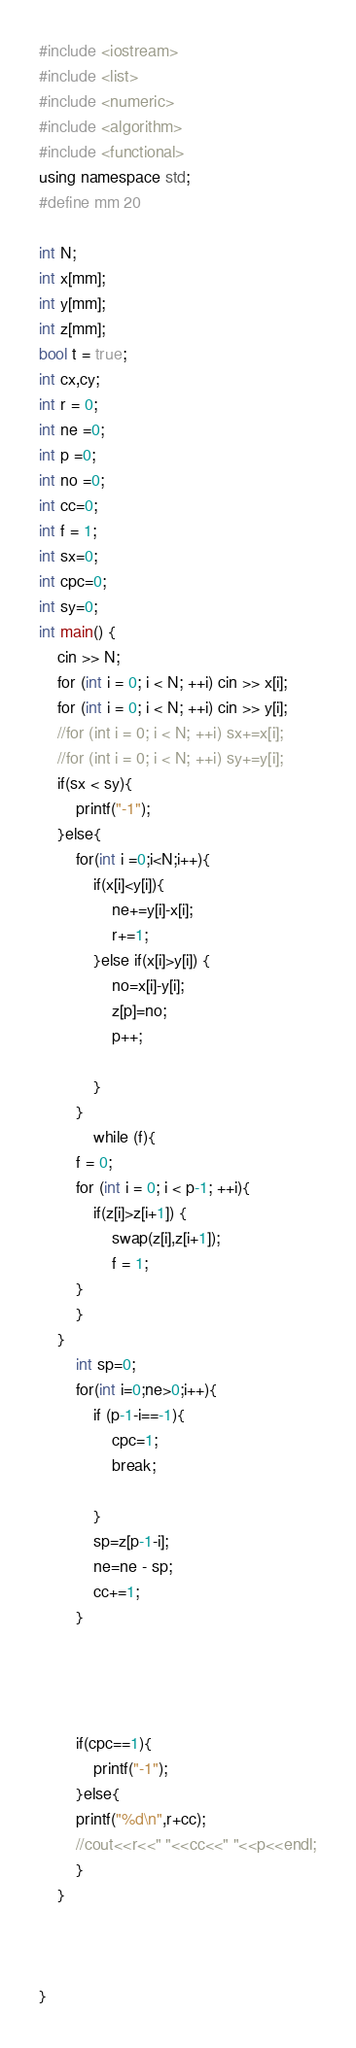<code> <loc_0><loc_0><loc_500><loc_500><_C++_>#include <iostream>
#include <list>
#include <numeric>
#include <algorithm>
#include <functional>
using namespace std;
#define mm 20

int N;
int x[mm];
int y[mm];
int z[mm];
bool t = true;  
int cx,cy;
int r = 0;
int ne =0;
int p =0;
int no =0;
int cc=0;
int f = 1;
int sx=0;
int cpc=0;
int sy=0;
int main() {
    cin >> N;
    for (int i = 0; i < N; ++i) cin >> x[i];
    for (int i = 0; i < N; ++i) cin >> y[i];
    //for (int i = 0; i < N; ++i) sx+=x[i];
    //for (int i = 0; i < N; ++i) sy+=y[i];
    if(sx < sy){
        printf("-1");
    }else{
        for(int i =0;i<N;i++){
            if(x[i]<y[i]){
                ne+=y[i]-x[i];
                r+=1;
            }else if(x[i]>y[i]) {
                no=x[i]-y[i];
                z[p]=no;
                p++;

            }
        }
            while (f){
        f = 0;
        for (int i = 0; i < p-1; ++i){
            if(z[i]>z[i+1]) {
                swap(z[i],z[i+1]);
                f = 1;
        }
        }
    }
        int sp=0;
        for(int i=0;ne>0;i++){
            if (p-1-i==-1){
                cpc=1;
                break;

            }
            sp=z[p-1-i];
            ne=ne - sp;
            cc+=1;
        }
        



        if(cpc==1){
            printf("-1");
        }else{
        printf("%d\n",r+cc);
        //cout<<r<<" "<<cc<<" "<<p<<endl;
        }
    }



}</code> 